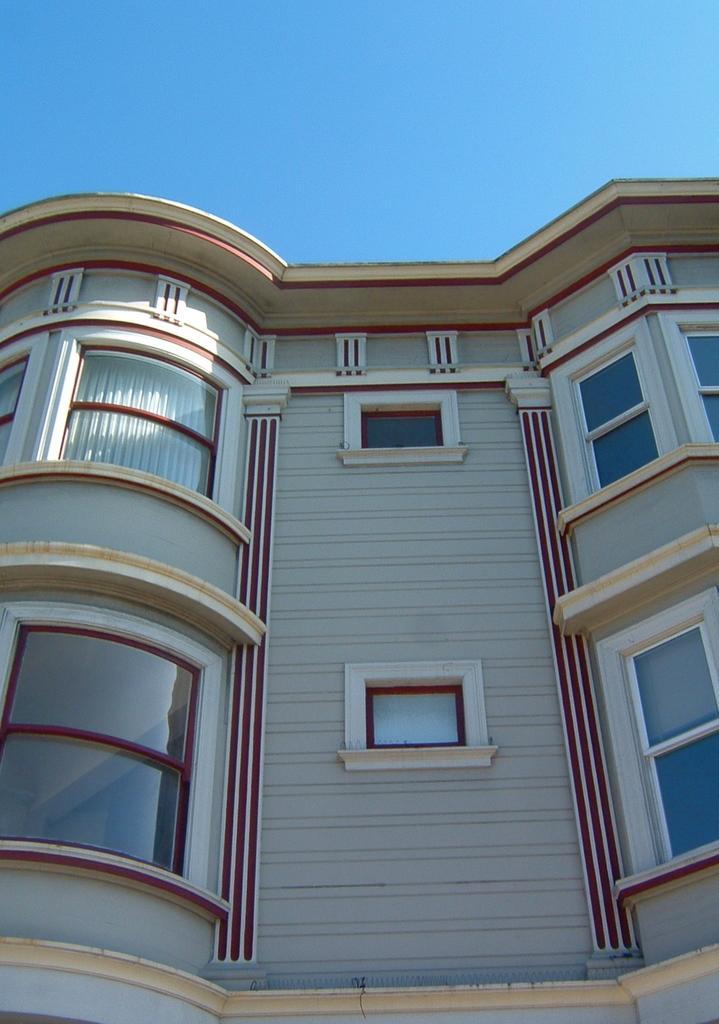Could you give a brief overview of what you see in this image? In this image I can see a building. On the building I can see red color designs. In the background I can see the sky. 